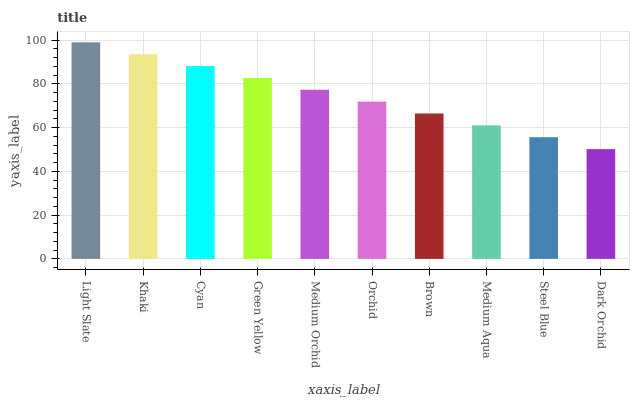Is Dark Orchid the minimum?
Answer yes or no. Yes. Is Light Slate the maximum?
Answer yes or no. Yes. Is Khaki the minimum?
Answer yes or no. No. Is Khaki the maximum?
Answer yes or no. No. Is Light Slate greater than Khaki?
Answer yes or no. Yes. Is Khaki less than Light Slate?
Answer yes or no. Yes. Is Khaki greater than Light Slate?
Answer yes or no. No. Is Light Slate less than Khaki?
Answer yes or no. No. Is Medium Orchid the high median?
Answer yes or no. Yes. Is Orchid the low median?
Answer yes or no. Yes. Is Medium Aqua the high median?
Answer yes or no. No. Is Cyan the low median?
Answer yes or no. No. 